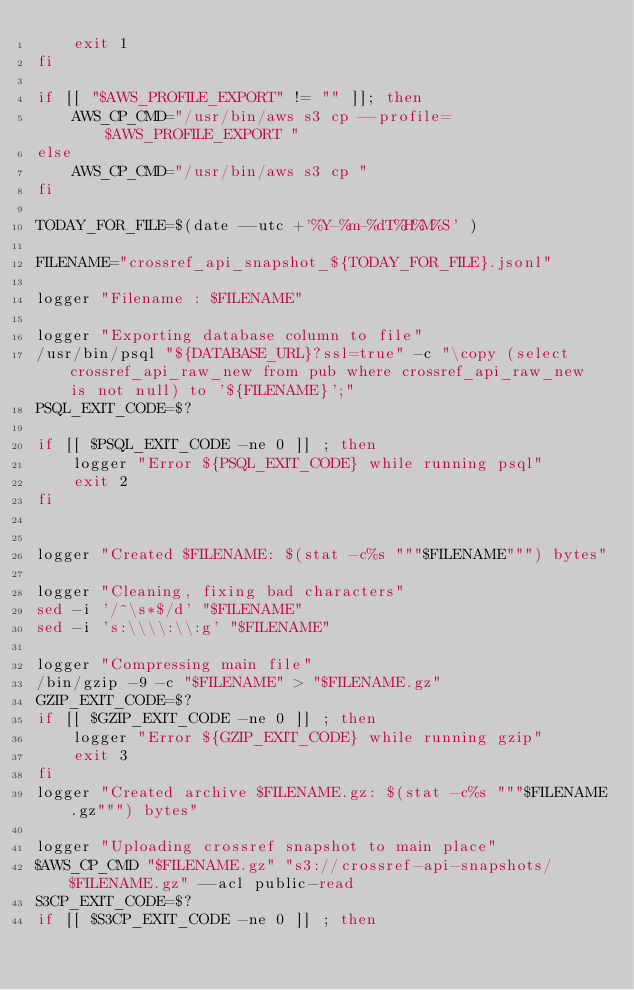<code> <loc_0><loc_0><loc_500><loc_500><_Bash_>    exit 1
fi

if [[ "$AWS_PROFILE_EXPORT" != "" ]]; then
    AWS_CP_CMD="/usr/bin/aws s3 cp --profile=$AWS_PROFILE_EXPORT "
else
    AWS_CP_CMD="/usr/bin/aws s3 cp "
fi

TODAY_FOR_FILE=$(date --utc +'%Y-%m-%dT%H%M%S' )

FILENAME="crossref_api_snapshot_${TODAY_FOR_FILE}.jsonl"

logger "Filename : $FILENAME"

logger "Exporting database column to file"
/usr/bin/psql "${DATABASE_URL}?ssl=true" -c "\copy (select crossref_api_raw_new from pub where crossref_api_raw_new is not null) to '${FILENAME}';"
PSQL_EXIT_CODE=$?

if [[ $PSQL_EXIT_CODE -ne 0 ]] ; then
    logger "Error ${PSQL_EXIT_CODE} while running psql"
    exit 2
fi


logger "Created $FILENAME: $(stat -c%s """$FILENAME""") bytes"

logger "Cleaning, fixing bad characters"
sed -i '/^\s*$/d' "$FILENAME"
sed -i 's:\\\\:\\:g' "$FILENAME"

logger "Compressing main file"
/bin/gzip -9 -c "$FILENAME" > "$FILENAME.gz"
GZIP_EXIT_CODE=$?
if [[ $GZIP_EXIT_CODE -ne 0 ]] ; then
    logger "Error ${GZIP_EXIT_CODE} while running gzip"
    exit 3
fi
logger "Created archive $FILENAME.gz: $(stat -c%s """$FILENAME.gz""") bytes"

logger "Uploading crossref snapshot to main place"
$AWS_CP_CMD "$FILENAME.gz" "s3://crossref-api-snapshots/$FILENAME.gz" --acl public-read
S3CP_EXIT_CODE=$?
if [[ $S3CP_EXIT_CODE -ne 0 ]] ; then</code> 